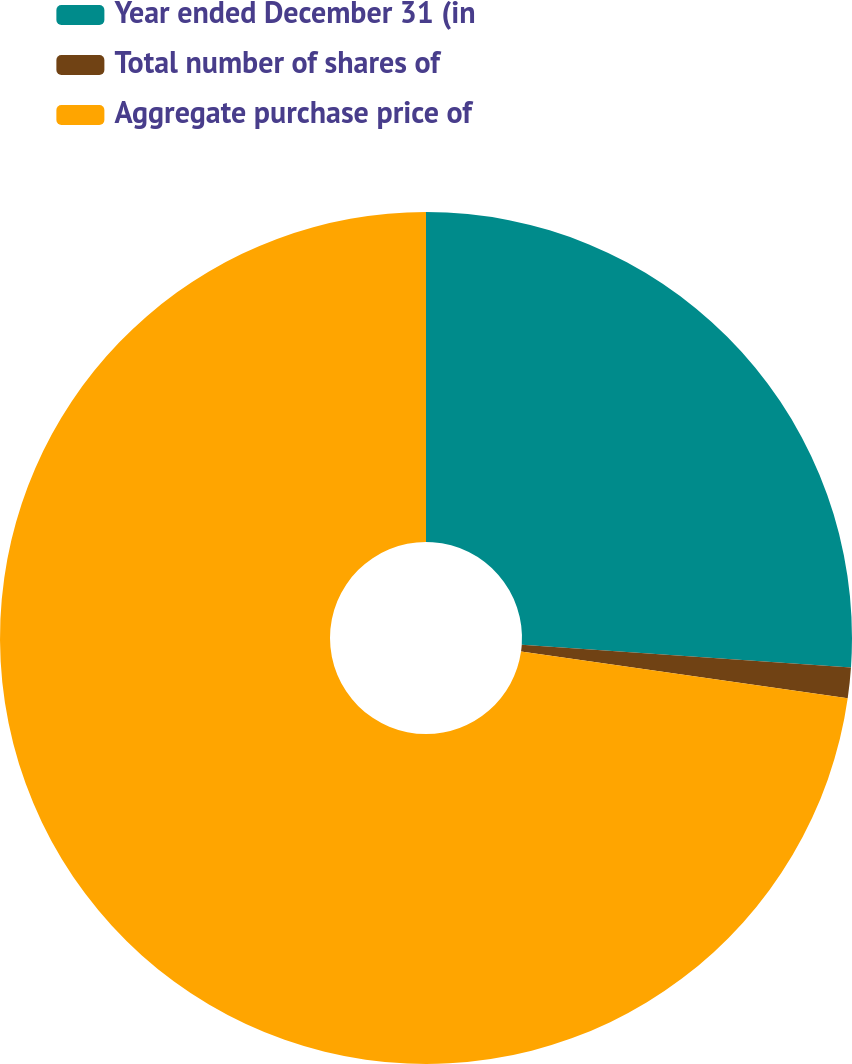Convert chart to OTSL. <chart><loc_0><loc_0><loc_500><loc_500><pie_chart><fcel>Year ended December 31 (in<fcel>Total number of shares of<fcel>Aggregate purchase price of<nl><fcel>26.1%<fcel>1.16%<fcel>72.74%<nl></chart> 